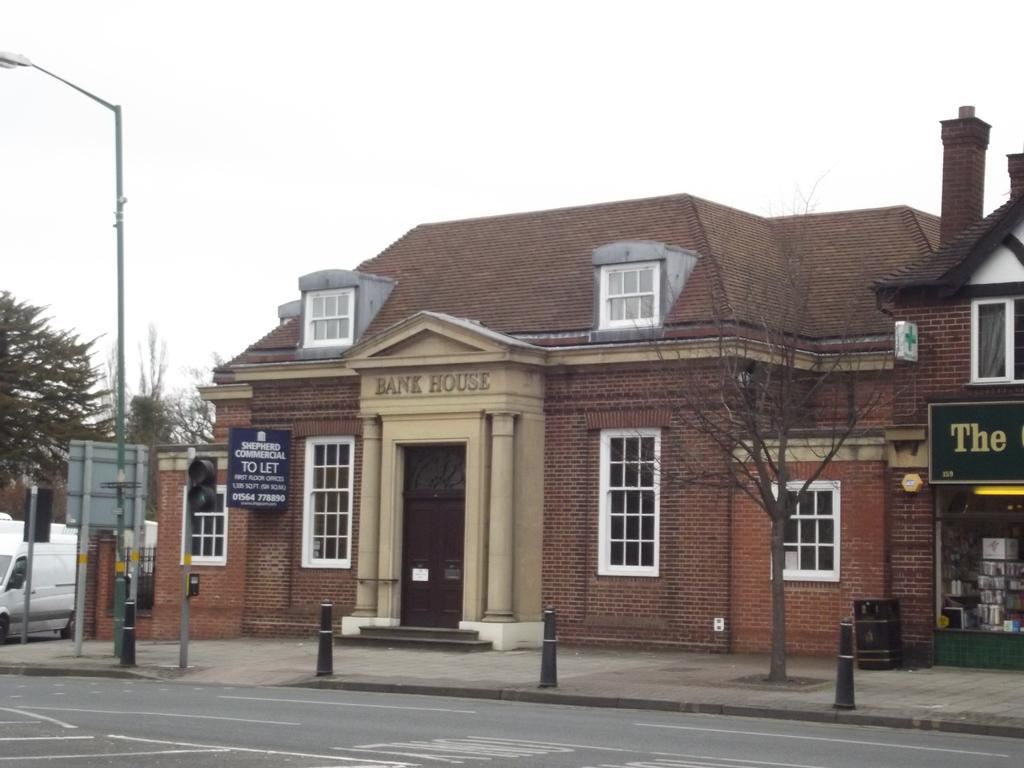What type of building can be seen in the image? There is a house with windows in the image. What other establishment is present in the image? There is a store in the image. What kind of signage is visible in the image? There is a hoarding in the image. What is the purpose of the tall structure in the image? There is a light pole in the image, which is used for illumination. What type of vegetation is present in the image? There are trees in the image. What mode of transportation is visible in the image? There is a vehicle in the image. How many brothers are depicted in the image? There are no brothers present in the image. What language is being spoken by the trees in the image? Trees do not speak any language, so this question cannot be answered. 